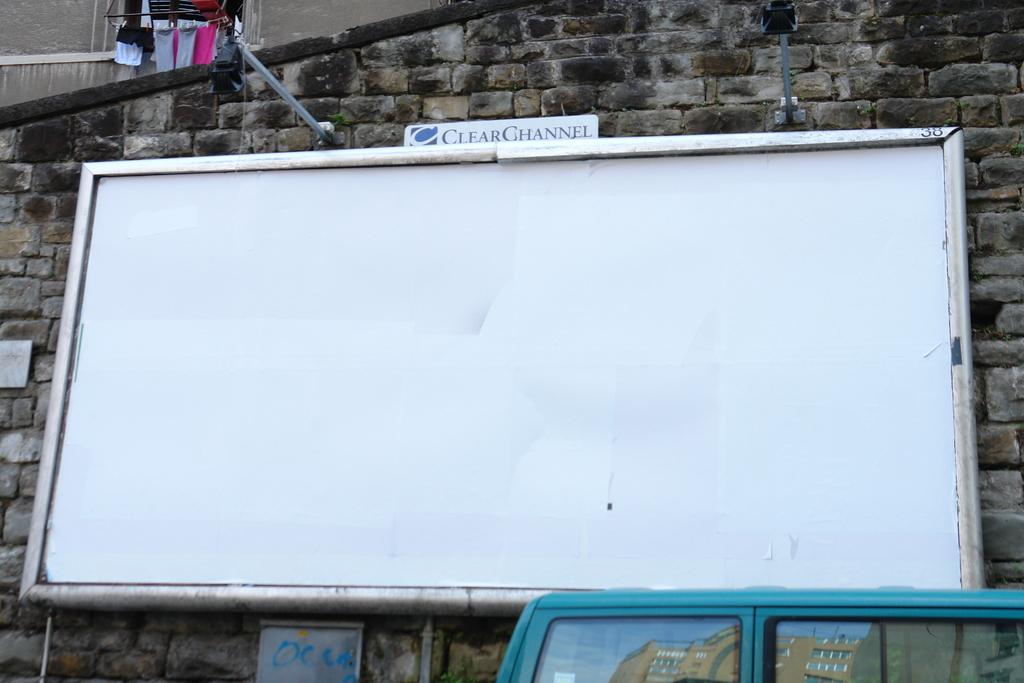<image>
Relay a brief, clear account of the picture shown. An empty whiteboard with Clear Channel on the  top 